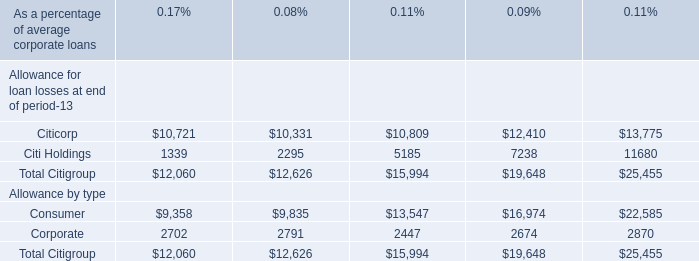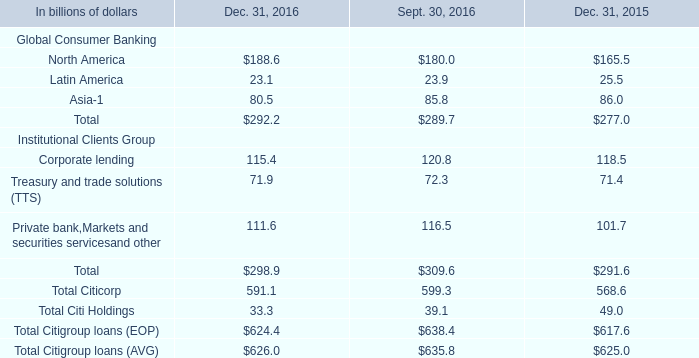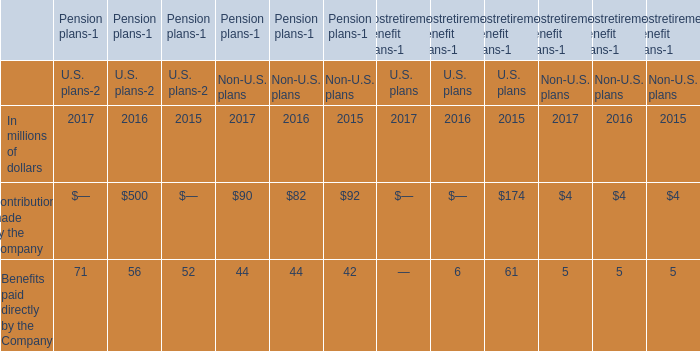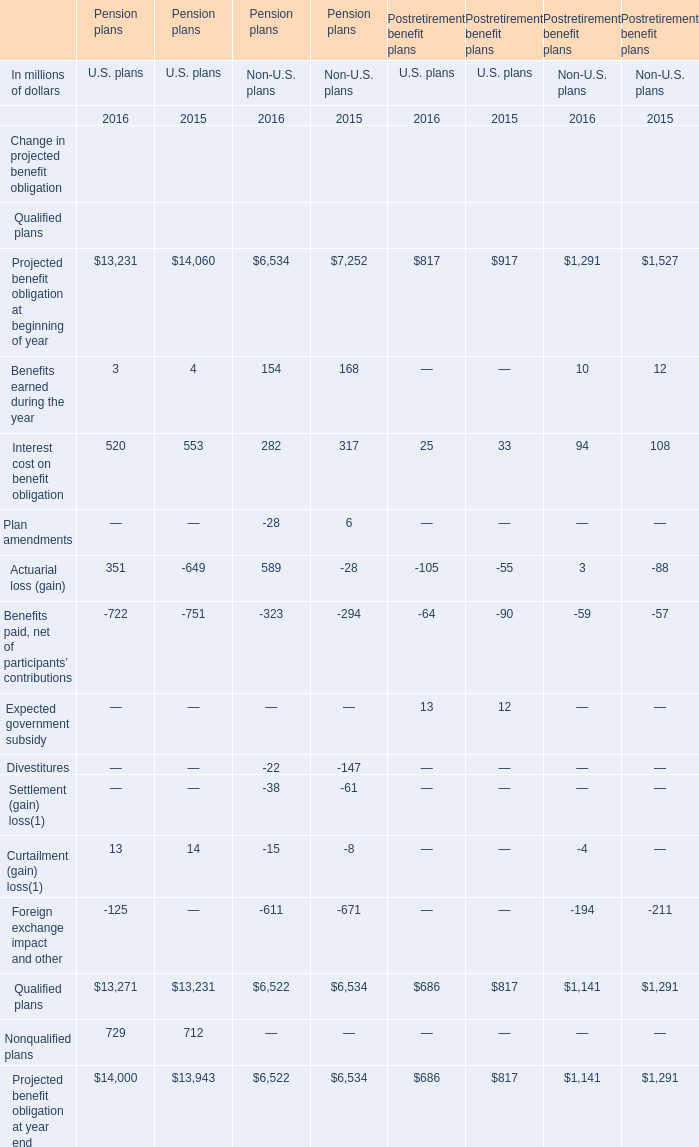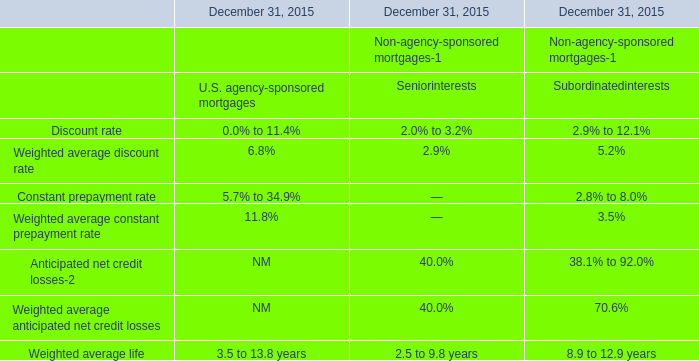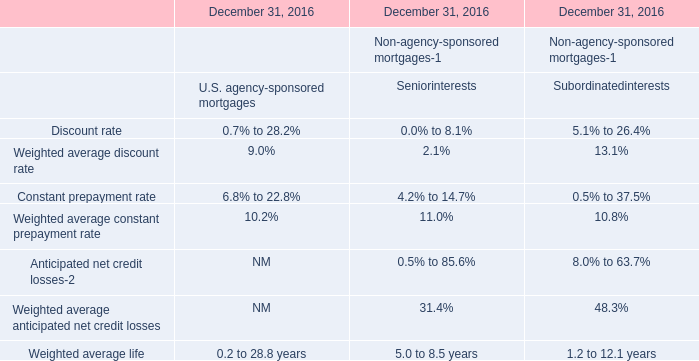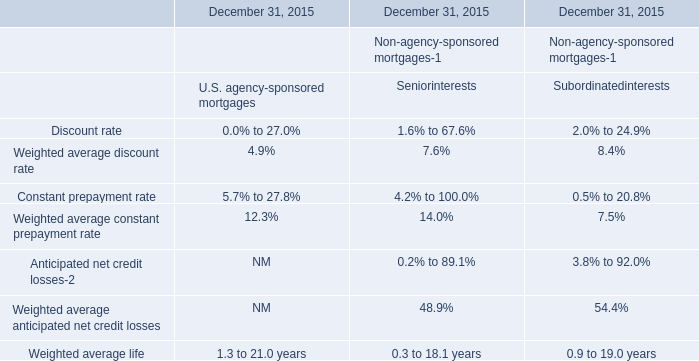What is the total value of Projected benefit obligation at beginning of year,Benefits earned during the year, Interest cost on benefit obligation and Qualified plans for Pension plans? (in million) 
Computations: (((((((((((((((13231 + 14060) + 6534) + 7252) + 3) + 4) + 154) + 168) + 520) + 553) + 282) + 317) + 13271) + 13231) + 6522) + 6534)
Answer: 82636.0. 